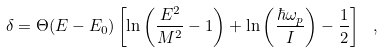Convert formula to latex. <formula><loc_0><loc_0><loc_500><loc_500>\delta = \Theta ( E - E _ { 0 } ) \left [ \ln \left ( \frac { E ^ { 2 } } { M ^ { 2 } } - 1 \right ) + \ln \left ( \frac { \hbar { \omega } _ { p } } { I } \right ) - \frac { 1 } { 2 } \right ] \ ,</formula> 